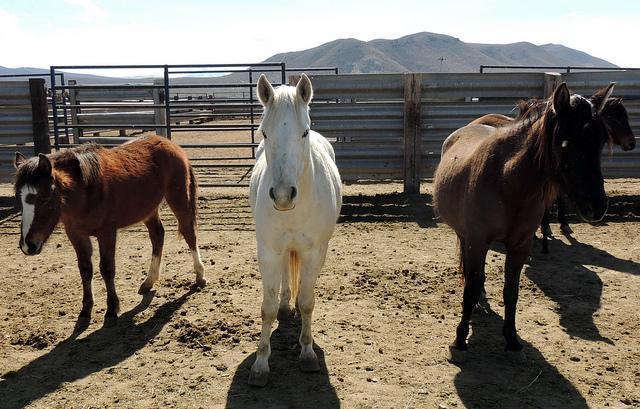How many horses are visible?
Give a very brief answer. 3. 